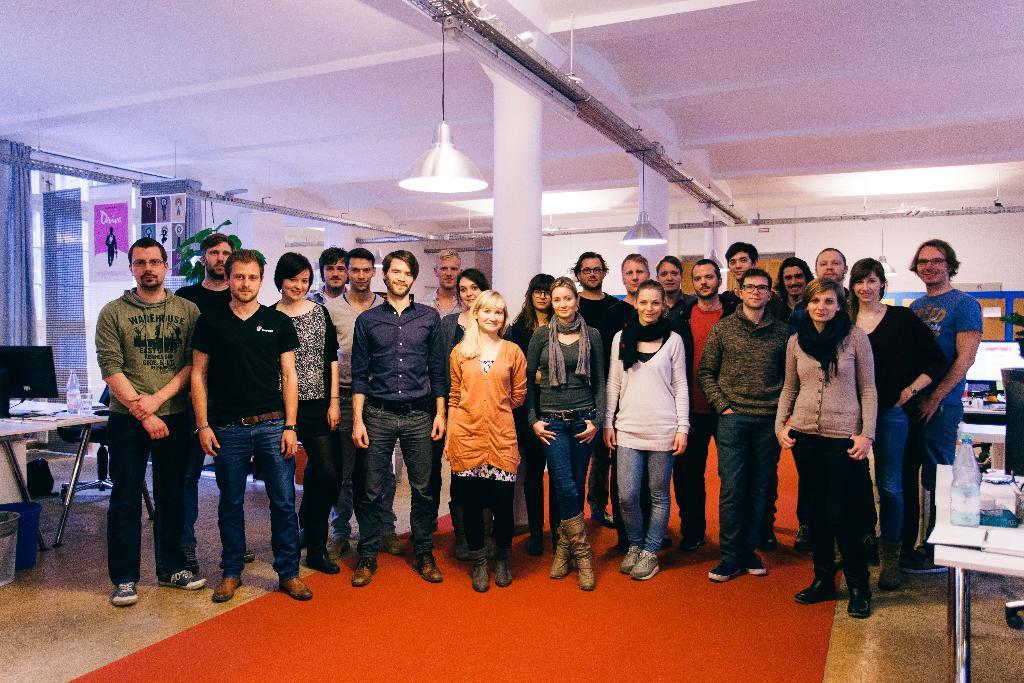In one or two sentences, can you explain what this image depicts? There are group of people standing and smiling. These are the lamps hanging. I can see the pillars. This looks like a curtain, which is hanging to the hanger. I can see a table with a laptop, water bottle, papers and few other things on it. On the left side of the image, I think these are the dustbins. This is a red carpet, which is on the floor. On the right side of the image, these look like the tables with a water bottle and few other objects on it. 